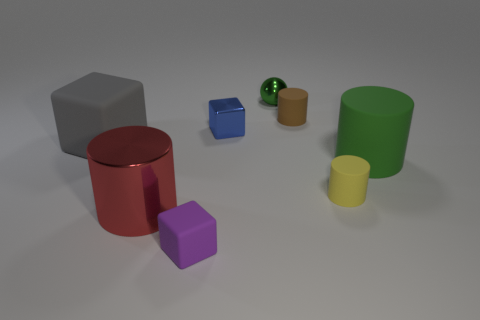Is the color of the big thing in front of the small yellow cylinder the same as the small cylinder that is in front of the blue metallic block?
Provide a succinct answer. No. Is there a cyan shiny thing?
Offer a terse response. No. Are there any big green cylinders that have the same material as the big gray object?
Offer a terse response. Yes. Is there anything else that is made of the same material as the small purple cube?
Your answer should be compact. Yes. What color is the metallic cube?
Your answer should be very brief. Blue. The big matte thing that is the same color as the metal sphere is what shape?
Your response must be concise. Cylinder. There is a matte cube that is the same size as the brown rubber object; what is its color?
Offer a terse response. Purple. How many shiny objects are either gray objects or yellow cylinders?
Offer a terse response. 0. What number of large matte things are on the left side of the shiny cylinder and right of the tiny metal sphere?
Provide a succinct answer. 0. Is there anything else that is the same shape as the green shiny object?
Keep it short and to the point. No. 